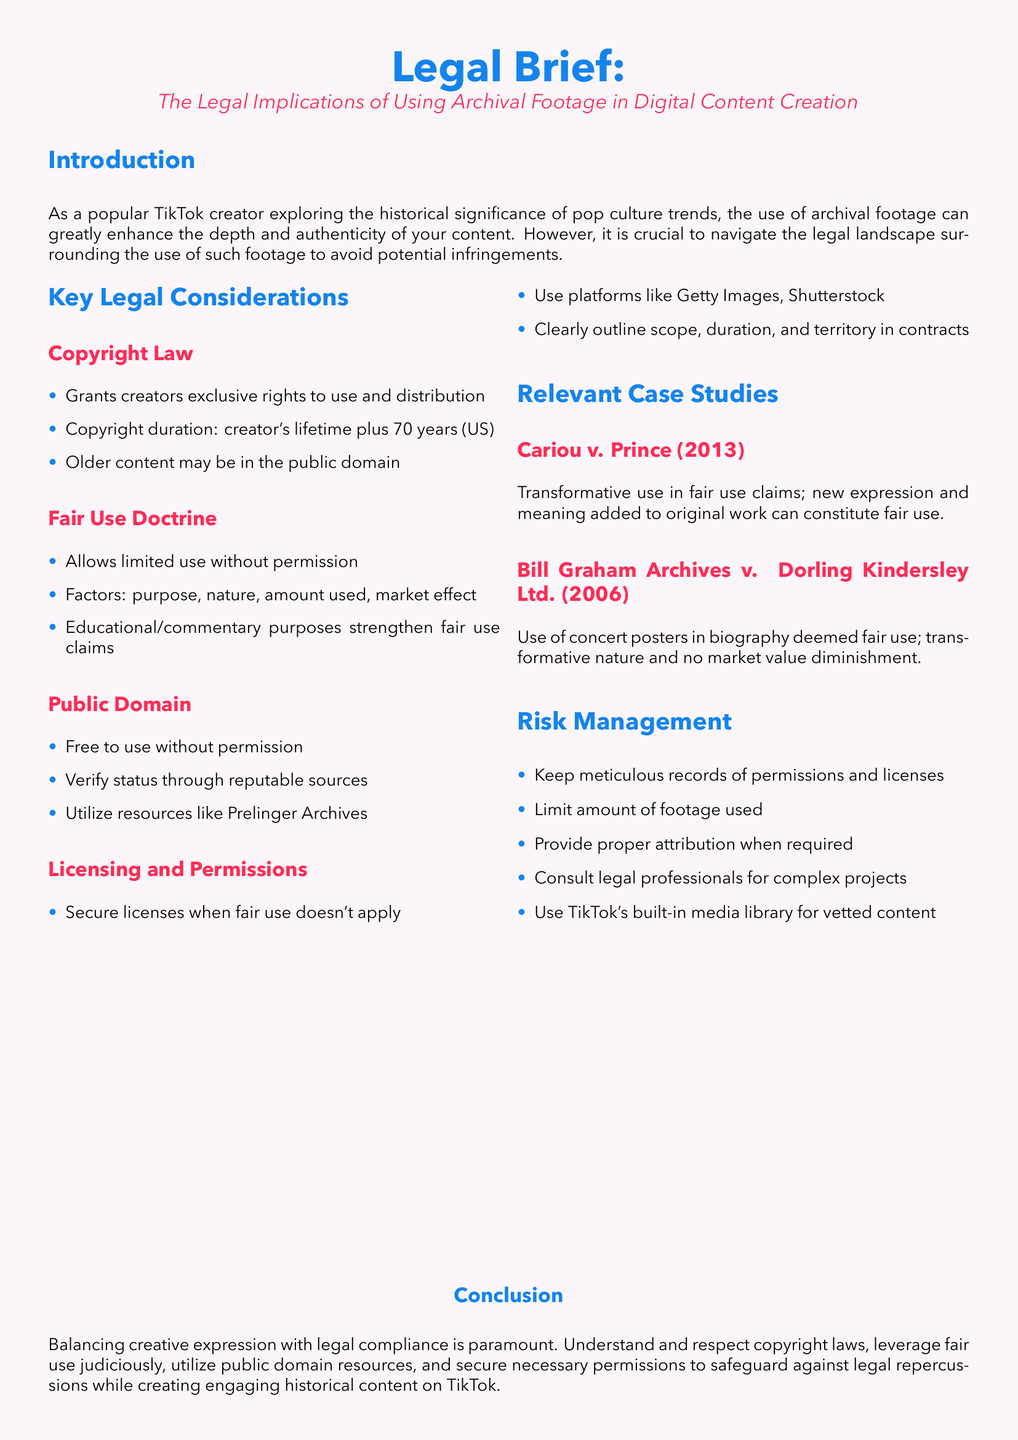What is the title of the legal brief? The title of the legal brief is prominently displayed in the document.
Answer: The Legal Implications of Using Archival Footage in Digital Content Creation What is the copyright duration in the US? The document mentions the duration of copyright protection as per law.
Answer: Creator's lifetime plus 70 years What allows limited use without permission? The document outlines a legal principle that allows certain usages without needing formal approval.
Answer: Fair Use Doctrine Which case dealt with transformative use in fair use claims? The document provides examples of relevant case studies pertaining to the use of archival footage.
Answer: Cariou v. Prince (2013) What resource can be used to verify public domain status? The document refers to a type of resource that can be utilized for checking public domain status.
Answer: Reputable sources What should creators do when fair use doesn’t apply? The document explains the action needed in this scenario regarding archived footage usage.
Answer: Secure licenses What is one risk management practice mentioned? The document includes suggestions to mitigate legal risks when using archival footage.
Answer: Keep meticulous records of permissions and licenses What does the conclusion emphasize? The conclusion of the document highlights the importance of balancing two specific aspects in content creation.
Answer: Creative expression with legal compliance 